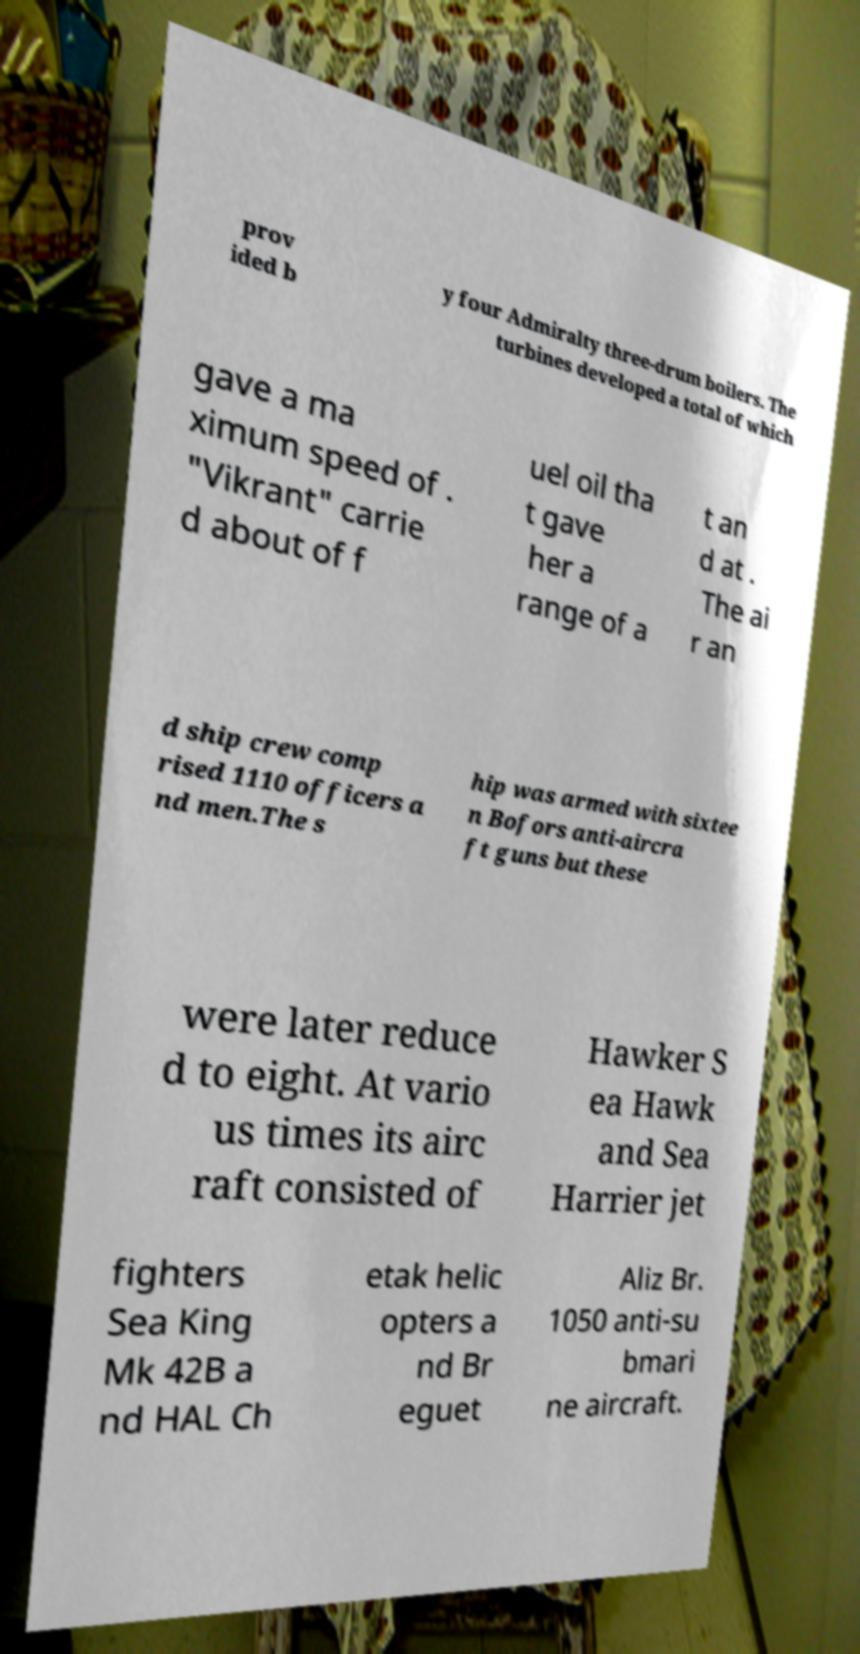Please identify and transcribe the text found in this image. prov ided b y four Admiralty three-drum boilers. The turbines developed a total of which gave a ma ximum speed of . "Vikrant" carrie d about of f uel oil tha t gave her a range of a t an d at . The ai r an d ship crew comp rised 1110 officers a nd men.The s hip was armed with sixtee n Bofors anti-aircra ft guns but these were later reduce d to eight. At vario us times its airc raft consisted of Hawker S ea Hawk and Sea Harrier jet fighters Sea King Mk 42B a nd HAL Ch etak helic opters a nd Br eguet Aliz Br. 1050 anti-su bmari ne aircraft. 